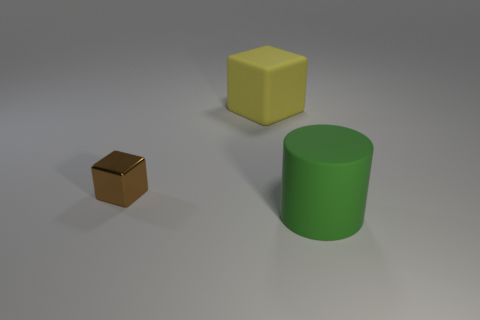Are the block that is in front of the yellow matte thing and the thing behind the small brown block made of the same material?
Make the answer very short. No. What color is the cylinder that is made of the same material as the yellow object?
Ensure brevity in your answer.  Green. How many blue matte cylinders are the same size as the yellow block?
Provide a short and direct response. 0. What number of other objects are the same color as the matte cylinder?
Keep it short and to the point. 0. Is there any other thing that has the same size as the yellow rubber cube?
Your answer should be compact. Yes. Is the shape of the big thing that is in front of the yellow rubber thing the same as the tiny brown object on the left side of the big matte cube?
Provide a short and direct response. No. There is a green rubber object that is the same size as the yellow matte thing; what is its shape?
Give a very brief answer. Cylinder. Is the number of small brown metallic objects that are in front of the brown shiny block the same as the number of yellow things left of the yellow thing?
Your answer should be very brief. Yes. Are there any other things that are the same shape as the brown shiny thing?
Offer a very short reply. Yes. Is the block behind the brown metallic block made of the same material as the tiny brown block?
Offer a very short reply. No. 